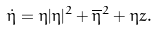<formula> <loc_0><loc_0><loc_500><loc_500>\dot { \eta } = \eta | \eta | ^ { 2 } + \overline { \eta } ^ { 2 } + \eta z .</formula> 